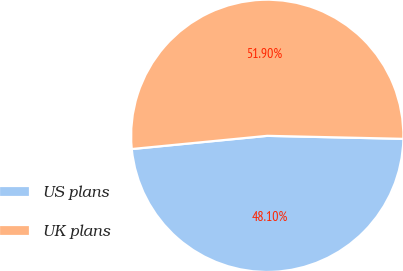Convert chart. <chart><loc_0><loc_0><loc_500><loc_500><pie_chart><fcel>US plans<fcel>UK plans<nl><fcel>48.1%<fcel>51.9%<nl></chart> 